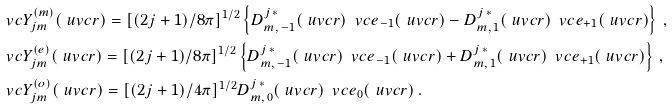Convert formula to latex. <formula><loc_0><loc_0><loc_500><loc_500>& \ v c { Y } _ { j m } ^ { ( m ) } ( \ u v c { r } ) = [ ( 2 j + 1 ) / 8 \pi ] ^ { 1 / 2 } \left \{ D _ { m , \, - 1 } ^ { j \, * } ( \ u v c { r } ) \, \ v c { e } _ { - 1 } ( \ u v c { r } ) - D _ { m , \, 1 } ^ { j \, * } ( \ u v c { r } ) \, \ v c { e } _ { + 1 } ( \ u v c { r } ) \right \} \, , \\ & \ v c { Y } _ { j m } ^ { ( e ) } ( \ u v c { r } ) = [ ( 2 j + 1 ) / 8 \pi ] ^ { 1 / 2 } \left \{ D _ { m , \, - 1 } ^ { j \, * } ( \ u v c { r } ) \, \ v c { e } _ { - 1 } ( \ u v c { r } ) + D _ { m , \, 1 } ^ { j \, * } ( \ u v c { r } ) \, \ v c { e } _ { + 1 } ( \ u v c { r } ) \right \} \, , \\ & \ v c { Y } _ { j m } ^ { ( o ) } ( \ u v c { r } ) = [ ( 2 j + 1 ) / 4 \pi ] ^ { 1 / 2 } D _ { m , \, 0 } ^ { j \, * } ( \ u v c { r } ) \, \ v c { e } _ { 0 } ( \ u v c { r } ) \, .</formula> 